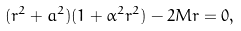<formula> <loc_0><loc_0><loc_500><loc_500>( r ^ { 2 } + a ^ { 2 } ) ( 1 + \alpha ^ { 2 } r ^ { 2 } ) - 2 M r = 0 ,</formula> 